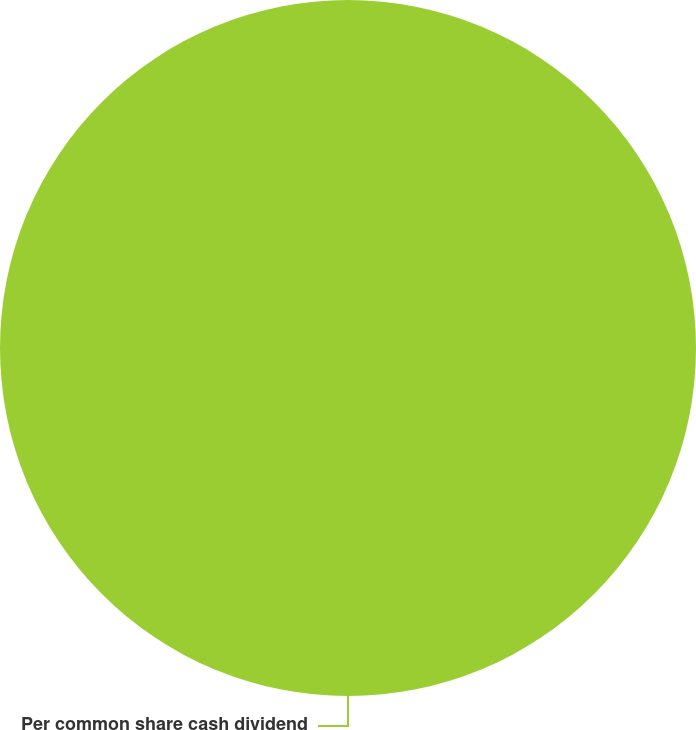Convert chart to OTSL. <chart><loc_0><loc_0><loc_500><loc_500><pie_chart><fcel>Per common share cash dividend<nl><fcel>100.0%<nl></chart> 